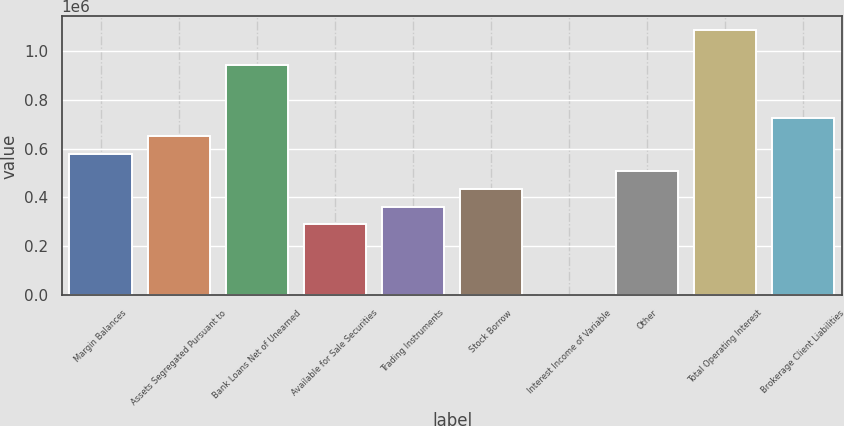<chart> <loc_0><loc_0><loc_500><loc_500><bar_chart><fcel>Margin Balances<fcel>Assets Segregated Pursuant to<fcel>Bank Loans Net of Unearned<fcel>Available for Sale Securities<fcel>Trading Instruments<fcel>Stock Borrow<fcel>Interest Income of Variable<fcel>Other<fcel>Total Operating Interest<fcel>Brokerage Client Liabilities<nl><fcel>579382<fcel>651722<fcel>941085<fcel>290019<fcel>362360<fcel>434701<fcel>657<fcel>507041<fcel>1.08577e+06<fcel>724063<nl></chart> 